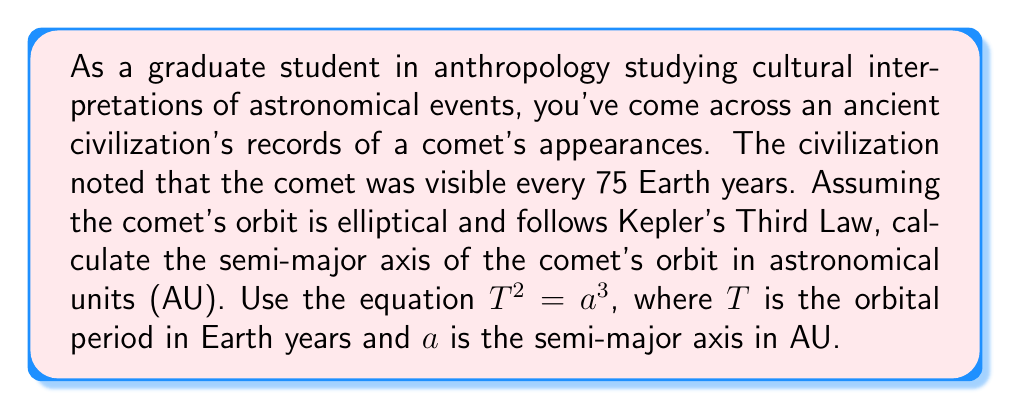Provide a solution to this math problem. To solve this problem, we'll use Kepler's Third Law of Planetary Motion, which states that the square of the orbital period of a planet is directly proportional to the cube of the semi-major axis of its orbit.

The equation is given as:

$$T^2 = a^3$$

Where:
$T$ = orbital period in Earth years
$a$ = semi-major axis in astronomical units (AU)

We are given:
$T = 75$ Earth years

Let's solve for $a$:

1) Start with the equation:
   $$T^2 = a^3$$

2) Substitute the known value of $T$:
   $$75^2 = a^3$$

3) Calculate the left side:
   $$5625 = a^3$$

4) Take the cube root of both sides:
   $$\sqrt[3]{5625} = a$$

5) Calculate the cube root:
   $$a \approx 17.9384$$

Therefore, the semi-major axis of the comet's orbit is approximately 17.9384 AU.
Answer: $a \approx 17.9384$ AU 